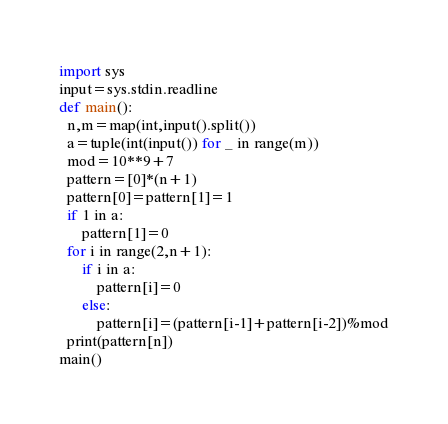<code> <loc_0><loc_0><loc_500><loc_500><_Python_>import sys
input=sys.stdin.readline
def main():
  n,m=map(int,input().split())
  a=tuple(int(input()) for _ in range(m))
  mod=10**9+7
  pattern=[0]*(n+1)
  pattern[0]=pattern[1]=1
  if 1 in a:
      pattern[1]=0
  for i in range(2,n+1):
      if i in a:
          pattern[i]=0
      else:
          pattern[i]=(pattern[i-1]+pattern[i-2])%mod
  print(pattern[n])
main()</code> 